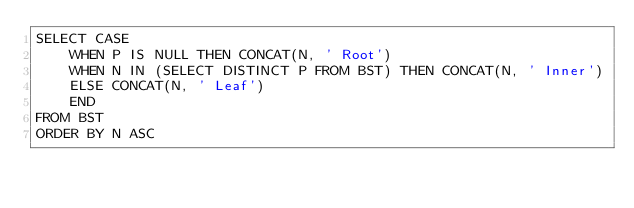<code> <loc_0><loc_0><loc_500><loc_500><_SQL_>SELECT CASE
    WHEN P IS NULL THEN CONCAT(N, ' Root')
    WHEN N IN (SELECT DISTINCT P FROM BST) THEN CONCAT(N, ' Inner')
    ELSE CONCAT(N, ' Leaf')
    END
FROM BST
ORDER BY N ASC</code> 